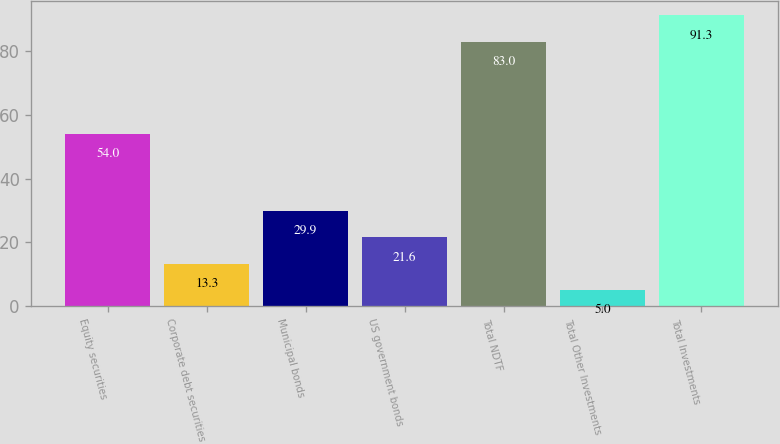Convert chart to OTSL. <chart><loc_0><loc_0><loc_500><loc_500><bar_chart><fcel>Equity securities<fcel>Corporate debt securities<fcel>Municipal bonds<fcel>US government bonds<fcel>Total NDTF<fcel>Total Other Investments<fcel>Total Investments<nl><fcel>54<fcel>13.3<fcel>29.9<fcel>21.6<fcel>83<fcel>5<fcel>91.3<nl></chart> 